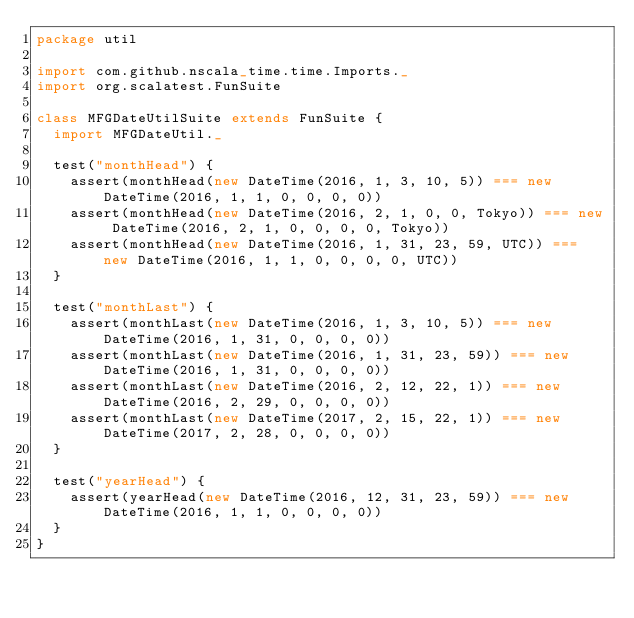<code> <loc_0><loc_0><loc_500><loc_500><_Scala_>package util

import com.github.nscala_time.time.Imports._
import org.scalatest.FunSuite

class MFGDateUtilSuite extends FunSuite {
  import MFGDateUtil._

  test("monthHead") {
    assert(monthHead(new DateTime(2016, 1, 3, 10, 5)) === new DateTime(2016, 1, 1, 0, 0, 0, 0))
    assert(monthHead(new DateTime(2016, 2, 1, 0, 0, Tokyo)) === new DateTime(2016, 2, 1, 0, 0, 0, 0, Tokyo))
    assert(monthHead(new DateTime(2016, 1, 31, 23, 59, UTC)) === new DateTime(2016, 1, 1, 0, 0, 0, 0, UTC))
  }

  test("monthLast") {
    assert(monthLast(new DateTime(2016, 1, 3, 10, 5)) === new DateTime(2016, 1, 31, 0, 0, 0, 0))
    assert(monthLast(new DateTime(2016, 1, 31, 23, 59)) === new DateTime(2016, 1, 31, 0, 0, 0, 0))
    assert(monthLast(new DateTime(2016, 2, 12, 22, 1)) === new DateTime(2016, 2, 29, 0, 0, 0, 0))
    assert(monthLast(new DateTime(2017, 2, 15, 22, 1)) === new DateTime(2017, 2, 28, 0, 0, 0, 0))
  }

  test("yearHead") {
    assert(yearHead(new DateTime(2016, 12, 31, 23, 59)) === new DateTime(2016, 1, 1, 0, 0, 0, 0))
  }
}

</code> 